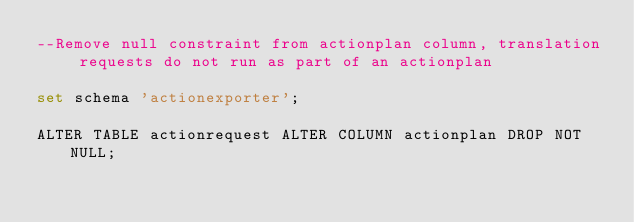<code> <loc_0><loc_0><loc_500><loc_500><_SQL_>--Remove null constraint from actionplan column, translation requests do not run as part of an actionplan

set schema 'actionexporter';

ALTER TABLE actionrequest ALTER COLUMN actionplan DROP NOT NULL;
</code> 